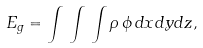<formula> <loc_0><loc_0><loc_500><loc_500>E _ { g } = \int \, \int \, \int \rho \, \phi \, d x d y d z ,</formula> 